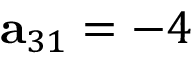<formula> <loc_0><loc_0><loc_500><loc_500>a _ { 3 1 } = - 4</formula> 